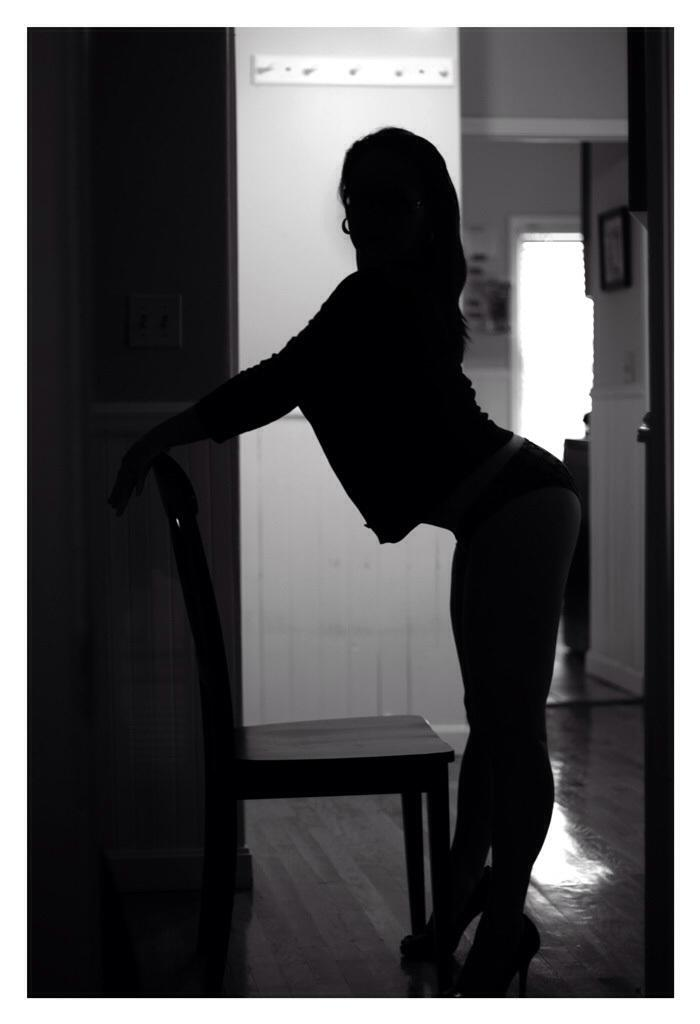Who or what is present in the image? There is a person in the image. What is the person doing in the image? The person is standing. Are there any objects in the image besides the person? Yes, there is a chair in the image. How many children are sitting on the coach in the image? There are no children or coaches present in the image. What type of glue is being used by the person in the image? There is no glue or indication of glue use in the image. 